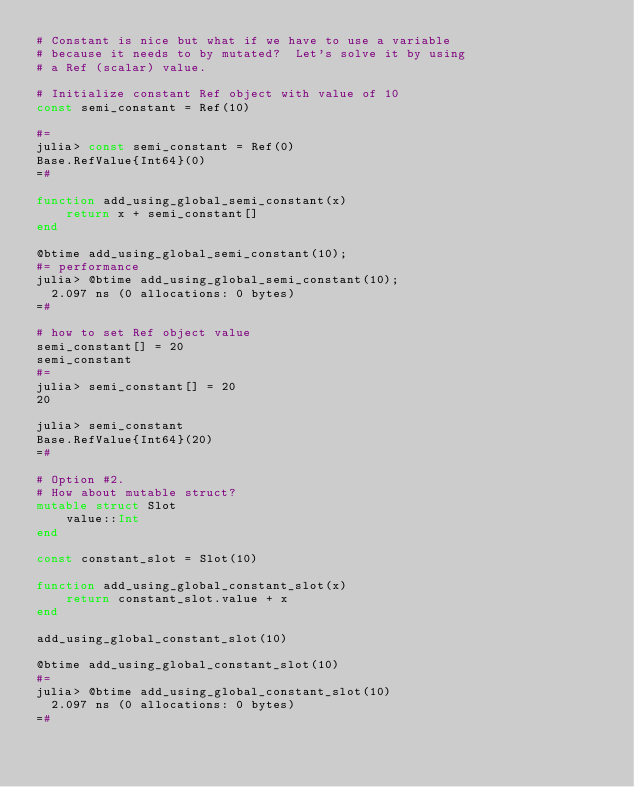Convert code to text. <code><loc_0><loc_0><loc_500><loc_500><_Julia_># Constant is nice but what if we have to use a variable
# because it needs to by mutated?  Let's solve it by using
# a Ref (scalar) value. 

# Initialize constant Ref object with value of 10
const semi_constant = Ref(10)

#=
julia> const semi_constant = Ref(0)
Base.RefValue{Int64}(0)
=#

function add_using_global_semi_constant(x)
    return x + semi_constant[]
end

@btime add_using_global_semi_constant(10);
#= performance
julia> @btime add_using_global_semi_constant(10);
  2.097 ns (0 allocations: 0 bytes)
=#

# how to set Ref object value
semi_constant[] = 20
semi_constant
#=
julia> semi_constant[] = 20
20

julia> semi_constant
Base.RefValue{Int64}(20)
=#

# Option #2.  
# How about mutable struct?
mutable struct Slot
    value::Int
end

const constant_slot = Slot(10)

function add_using_global_constant_slot(x)
    return constant_slot.value + x
end

add_using_global_constant_slot(10)

@btime add_using_global_constant_slot(10)
#=
julia> @btime add_using_global_constant_slot(10)
  2.097 ns (0 allocations: 0 bytes)
=#</code> 